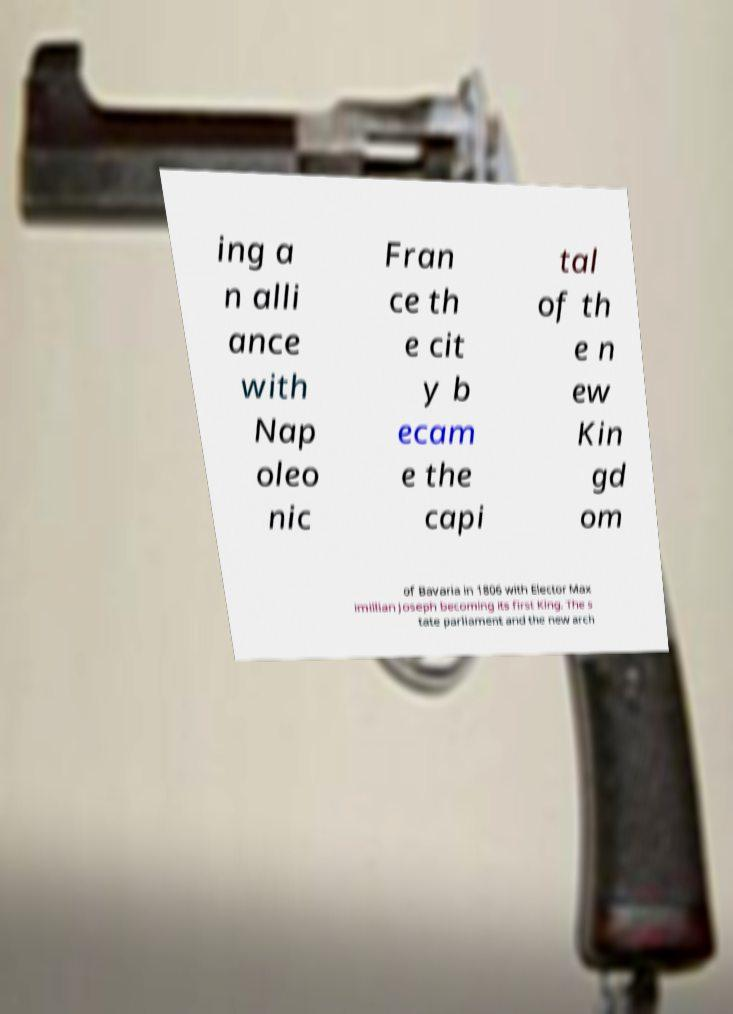Could you extract and type out the text from this image? ing a n alli ance with Nap oleo nic Fran ce th e cit y b ecam e the capi tal of th e n ew Kin gd om of Bavaria in 1806 with Elector Max imillian Joseph becoming its first King. The s tate parliament and the new arch 